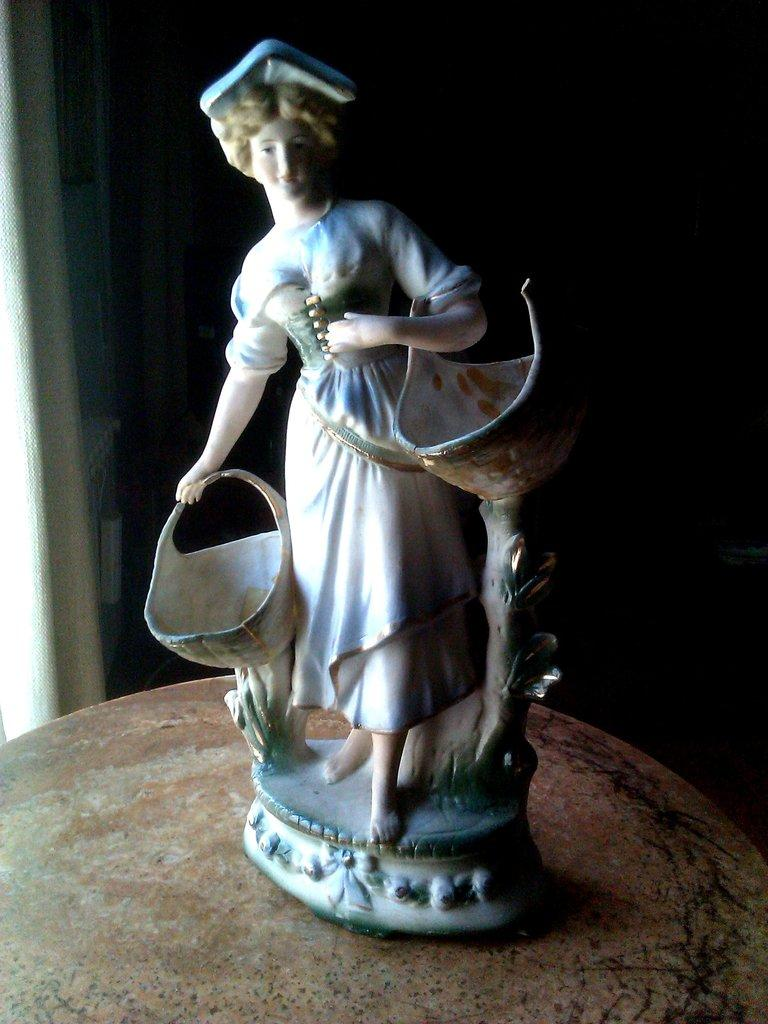What is the main object in the image? There is a table in the image. What is placed on the table? There is a figurine on the table. What type of destruction is depicted in the image? There is no destruction depicted in the image; it only features a table and a figurine. Is the table being used as a desk in the image? The image does not provide enough information to determine if the table is being used as a desk or for any other purpose. What type of wealth is represented by the figurine in the image? The image does not provide enough information to determine if the figurine represents any type of wealth. 